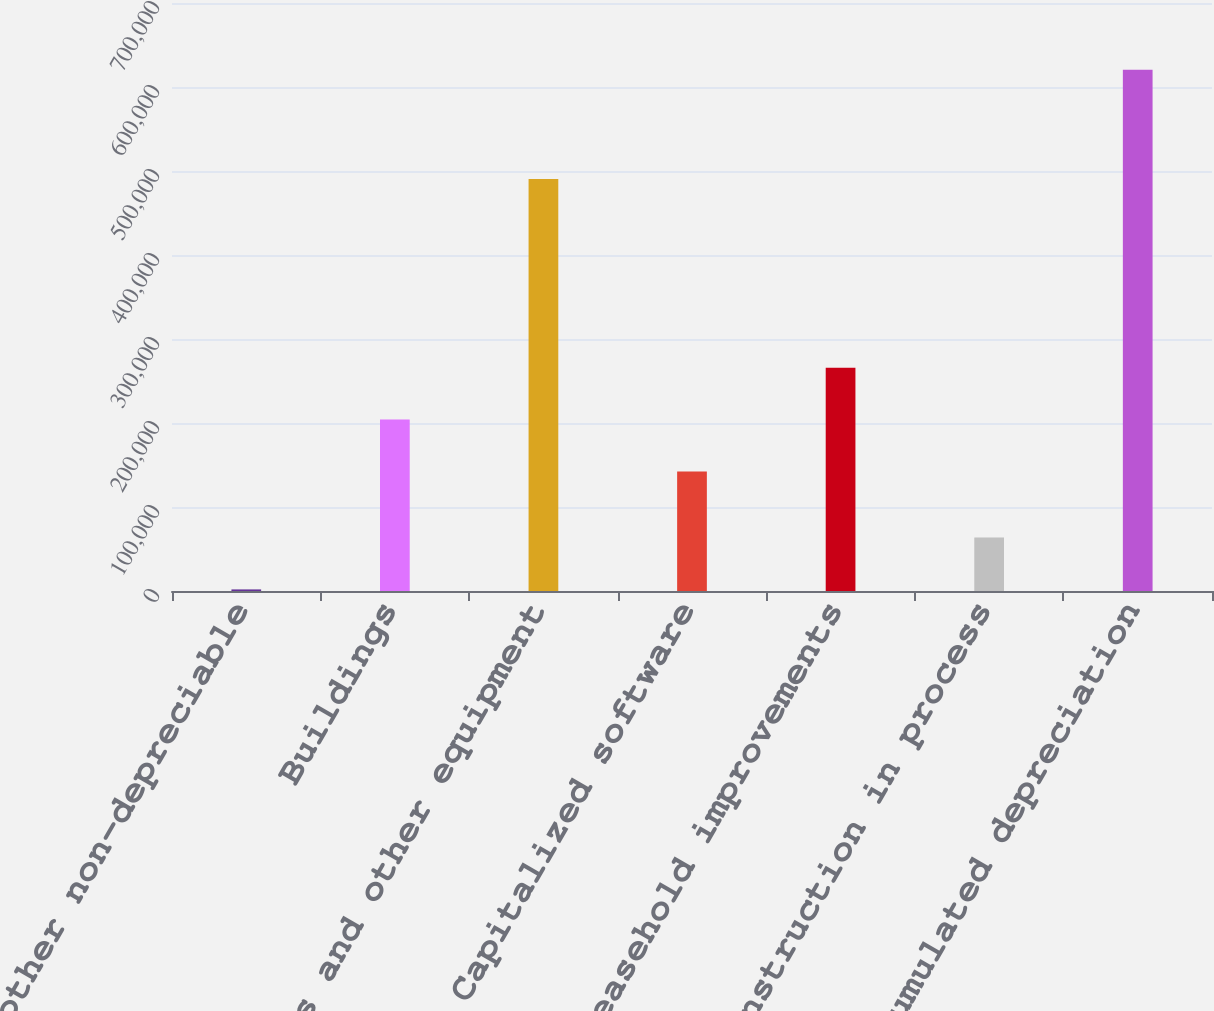Convert chart to OTSL. <chart><loc_0><loc_0><loc_500><loc_500><bar_chart><fcel>Land and other non-depreciable<fcel>Buildings<fcel>Computers and other equipment<fcel>Capitalized software<fcel>Leasehold improvements<fcel>Construction in process<fcel>Less Accumulated depreciation<nl><fcel>1887<fcel>204021<fcel>490365<fcel>142164<fcel>265879<fcel>63744.3<fcel>620460<nl></chart> 